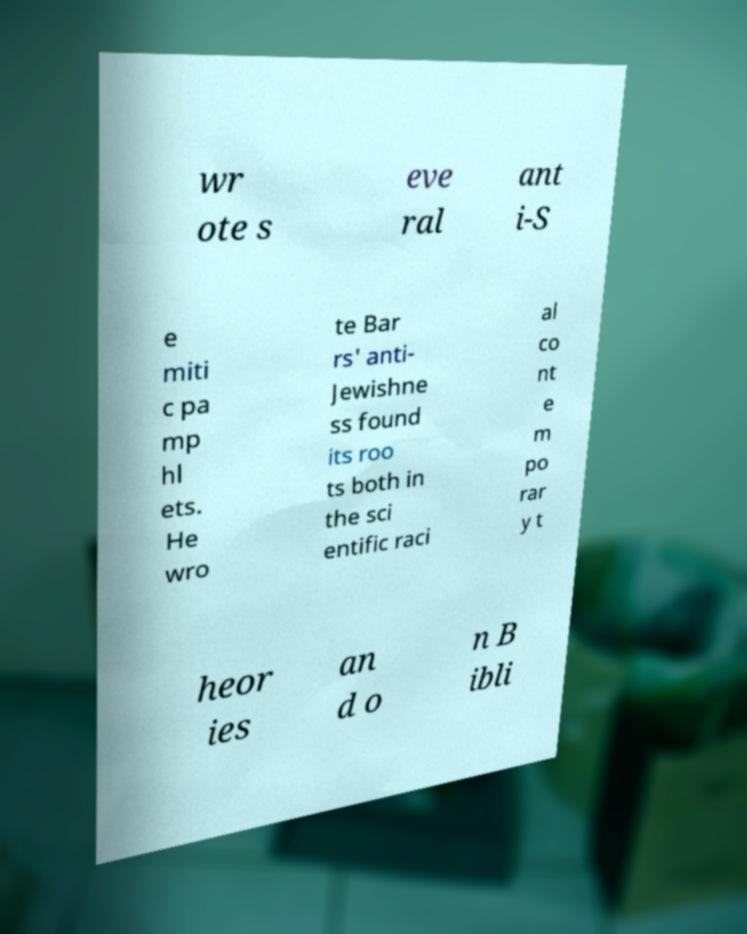I need the written content from this picture converted into text. Can you do that? wr ote s eve ral ant i-S e miti c pa mp hl ets. He wro te Bar rs' anti- Jewishne ss found its roo ts both in the sci entific raci al co nt e m po rar y t heor ies an d o n B ibli 